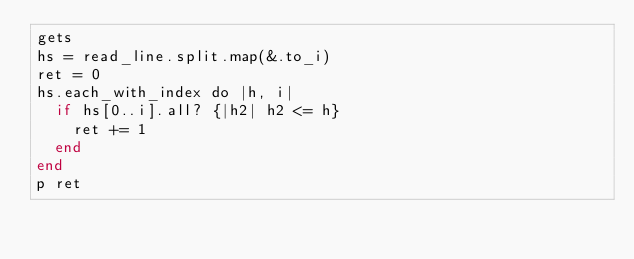Convert code to text. <code><loc_0><loc_0><loc_500><loc_500><_Crystal_>gets
hs = read_line.split.map(&.to_i)
ret = 0
hs.each_with_index do |h, i|
  if hs[0..i].all? {|h2| h2 <= h}
    ret += 1
  end
end
p ret</code> 